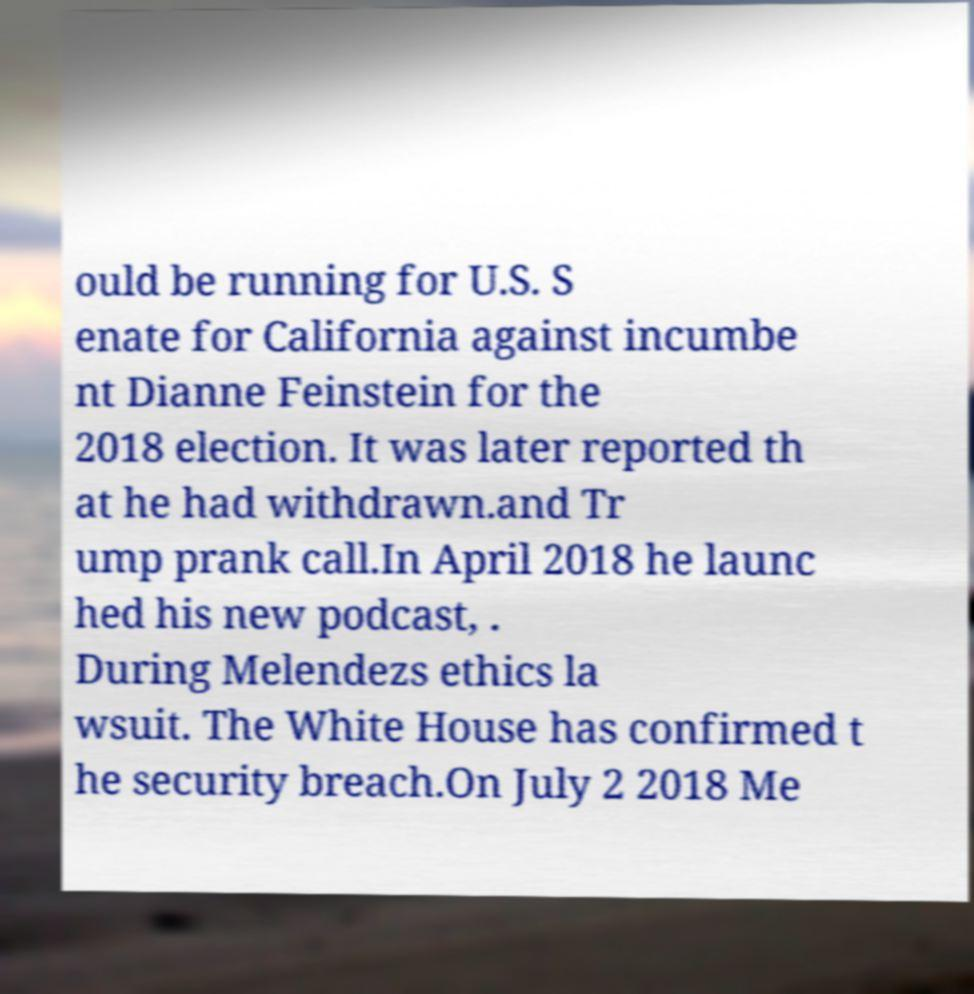Can you accurately transcribe the text from the provided image for me? ould be running for U.S. S enate for California against incumbe nt Dianne Feinstein for the 2018 election. It was later reported th at he had withdrawn.and Tr ump prank call.In April 2018 he launc hed his new podcast, . During Melendezs ethics la wsuit. The White House has confirmed t he security breach.On July 2 2018 Me 